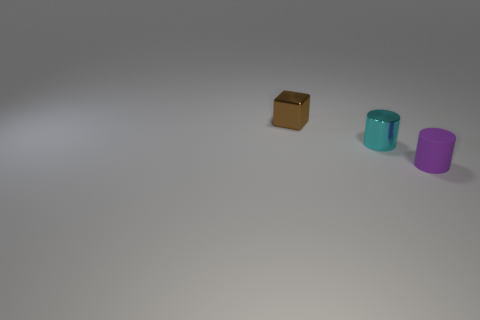Are there any purple cylinders made of the same material as the cyan cylinder?
Your response must be concise. No. There is a cylinder that is behind the purple rubber object; is it the same size as the shiny thing behind the small cyan metallic cylinder?
Give a very brief answer. Yes. There is a shiny object that is in front of the brown metallic thing; how big is it?
Your answer should be compact. Small. Are there any things that have the same color as the tiny rubber cylinder?
Give a very brief answer. No. There is a shiny object to the right of the brown metallic cube; are there any brown objects that are in front of it?
Your response must be concise. No. There is a brown metal block; is its size the same as the metal object that is in front of the tiny brown thing?
Your answer should be very brief. Yes. There is a small thing that is in front of the small metal object that is in front of the cube; is there a small purple thing that is behind it?
Ensure brevity in your answer.  No. There is a cylinder on the right side of the cyan metallic object; what material is it?
Keep it short and to the point. Rubber. Do the cube and the cyan thing have the same size?
Provide a short and direct response. Yes. What color is the object that is on the left side of the purple matte thing and to the right of the brown cube?
Provide a short and direct response. Cyan. 